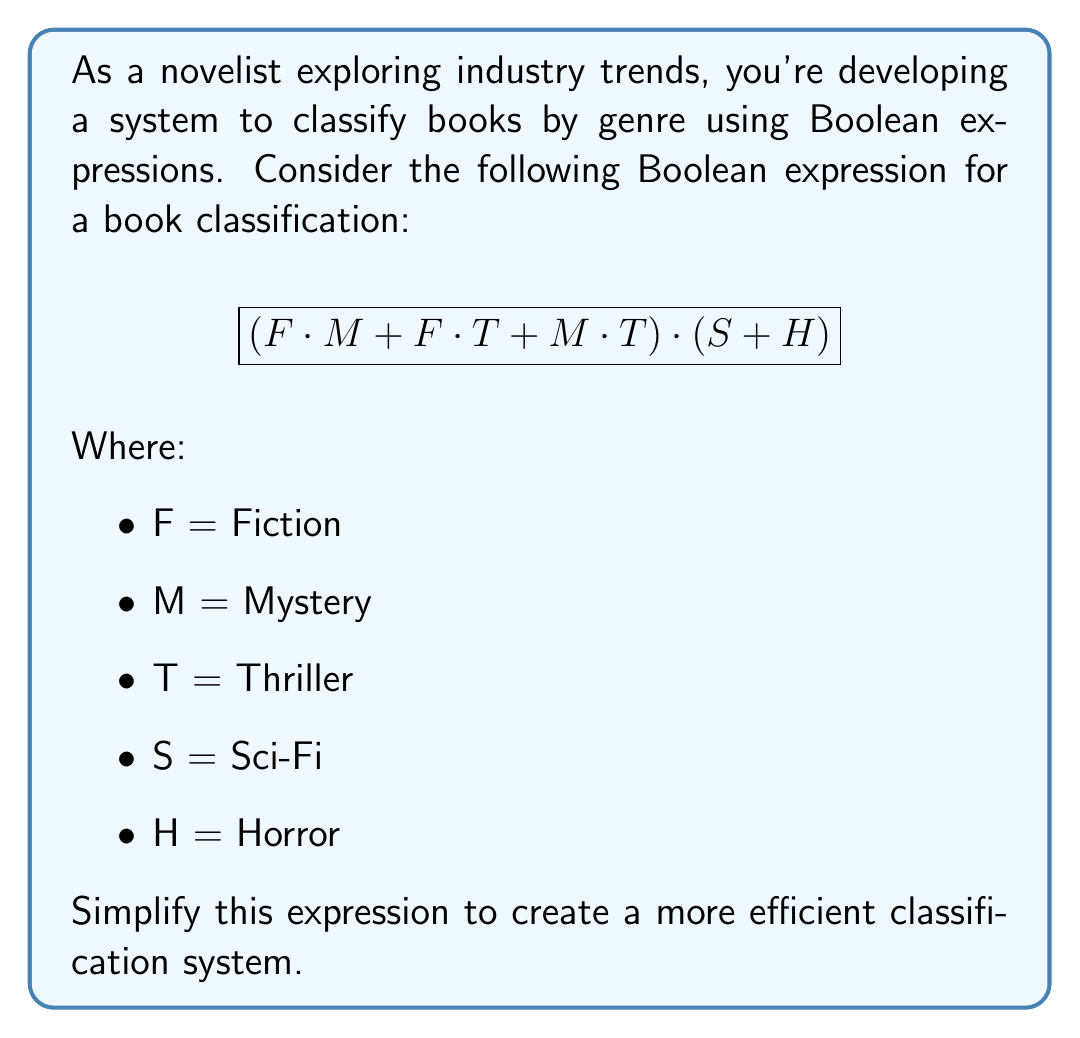Teach me how to tackle this problem. Let's simplify this Boolean expression step-by-step:

1. First, let's focus on the part inside the first parentheses: $(F \cdot M + F \cdot T + M \cdot T)$

2. We can factor out $F$ from the first two terms:
   $F(M + T) + M \cdot T$

3. Now, we can apply the distributive law:
   $FM + FT + MT$

4. This expression $(FM + FT + MT)$ is in the form of $xy + xz + yz$, which is equivalent to $(x + y)(x + z)$. So we can rewrite it as:
   $(F + M)(F + T)$

5. Now our entire expression looks like this:
   $$(F + M)(F + T) \cdot (S + H)$$

6. We can't simplify this further because $(S + H)$ is independent of the other terms.

This simplified expression represents a more efficient classification system. It means a book is classified in this category if it's either Fiction or Mystery, AND either Fiction or Thriller, AND either Sci-Fi or Horror.
Answer: $$(F + M)(F + T)(S + H)$$ 